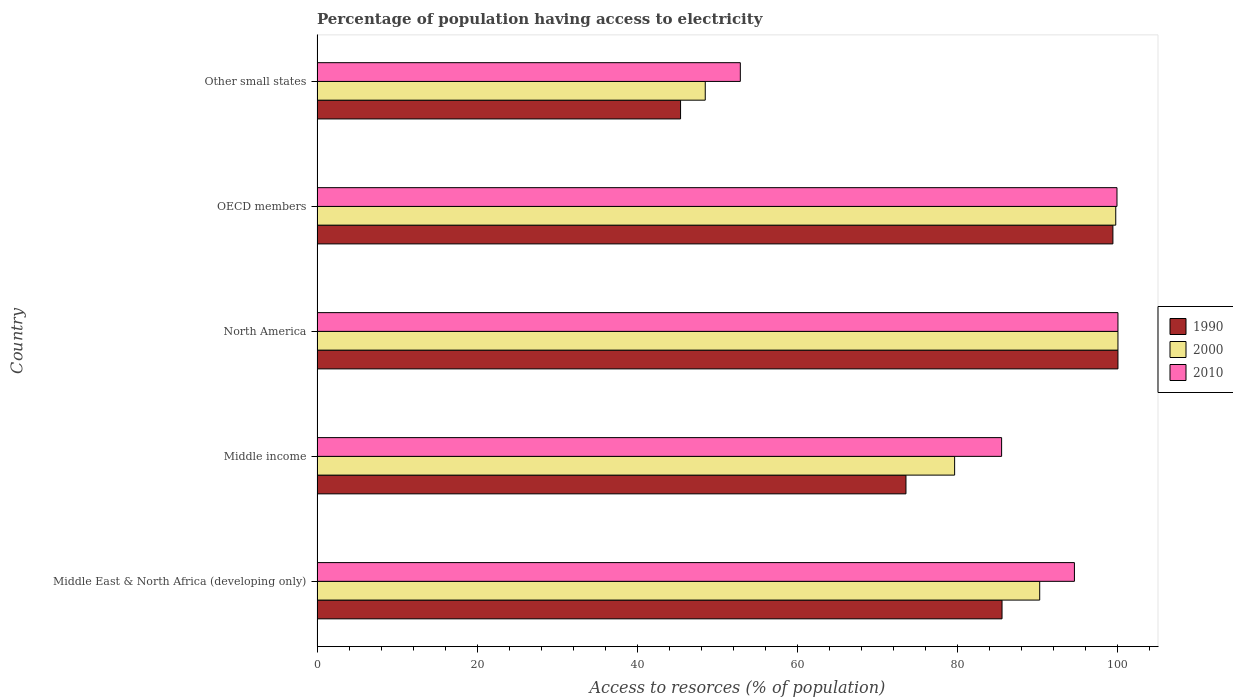How many different coloured bars are there?
Give a very brief answer. 3. What is the label of the 4th group of bars from the top?
Your response must be concise. Middle income. In how many cases, is the number of bars for a given country not equal to the number of legend labels?
Keep it short and to the point. 0. What is the percentage of population having access to electricity in 2000 in OECD members?
Your answer should be compact. 99.72. Across all countries, what is the maximum percentage of population having access to electricity in 2000?
Offer a terse response. 100. Across all countries, what is the minimum percentage of population having access to electricity in 2010?
Your answer should be compact. 52.85. In which country was the percentage of population having access to electricity in 2010 minimum?
Make the answer very short. Other small states. What is the total percentage of population having access to electricity in 1990 in the graph?
Ensure brevity in your answer.  403.82. What is the difference between the percentage of population having access to electricity in 2000 in OECD members and that in Other small states?
Provide a succinct answer. 51.25. What is the difference between the percentage of population having access to electricity in 2000 in Middle income and the percentage of population having access to electricity in 2010 in Middle East & North Africa (developing only)?
Make the answer very short. -14.96. What is the average percentage of population having access to electricity in 2000 per country?
Offer a very short reply. 83.61. What is the difference between the percentage of population having access to electricity in 1990 and percentage of population having access to electricity in 2000 in North America?
Offer a terse response. 0. What is the ratio of the percentage of population having access to electricity in 1990 in North America to that in OECD members?
Provide a succinct answer. 1.01. Is the percentage of population having access to electricity in 2010 in OECD members less than that in Other small states?
Provide a succinct answer. No. What is the difference between the highest and the second highest percentage of population having access to electricity in 1990?
Provide a short and direct response. 0.63. What is the difference between the highest and the lowest percentage of population having access to electricity in 1990?
Make the answer very short. 54.61. In how many countries, is the percentage of population having access to electricity in 1990 greater than the average percentage of population having access to electricity in 1990 taken over all countries?
Make the answer very short. 3. What does the 3rd bar from the bottom in Middle income represents?
Offer a very short reply. 2010. How many countries are there in the graph?
Your answer should be compact. 5. Does the graph contain grids?
Your answer should be compact. No. Where does the legend appear in the graph?
Your answer should be compact. Center right. How are the legend labels stacked?
Offer a very short reply. Vertical. What is the title of the graph?
Provide a short and direct response. Percentage of population having access to electricity. Does "2007" appear as one of the legend labels in the graph?
Your answer should be very brief. No. What is the label or title of the X-axis?
Offer a very short reply. Access to resorces (% of population). What is the label or title of the Y-axis?
Offer a very short reply. Country. What is the Access to resorces (% of population) of 1990 in Middle East & North Africa (developing only)?
Keep it short and to the point. 85.53. What is the Access to resorces (% of population) in 2000 in Middle East & North Africa (developing only)?
Your response must be concise. 90.23. What is the Access to resorces (% of population) of 2010 in Middle East & North Africa (developing only)?
Offer a very short reply. 94.57. What is the Access to resorces (% of population) in 1990 in Middle income?
Provide a short and direct response. 73.53. What is the Access to resorces (% of population) of 2000 in Middle income?
Offer a very short reply. 79.61. What is the Access to resorces (% of population) in 2010 in Middle income?
Your answer should be very brief. 85.47. What is the Access to resorces (% of population) of 1990 in North America?
Offer a terse response. 100. What is the Access to resorces (% of population) in 2000 in North America?
Provide a short and direct response. 100. What is the Access to resorces (% of population) of 2010 in North America?
Offer a very short reply. 100. What is the Access to resorces (% of population) of 1990 in OECD members?
Provide a short and direct response. 99.37. What is the Access to resorces (% of population) in 2000 in OECD members?
Give a very brief answer. 99.72. What is the Access to resorces (% of population) in 2010 in OECD members?
Your answer should be very brief. 99.88. What is the Access to resorces (% of population) of 1990 in Other small states?
Your answer should be very brief. 45.39. What is the Access to resorces (% of population) in 2000 in Other small states?
Your answer should be very brief. 48.47. What is the Access to resorces (% of population) of 2010 in Other small states?
Provide a succinct answer. 52.85. Across all countries, what is the maximum Access to resorces (% of population) of 2000?
Ensure brevity in your answer.  100. Across all countries, what is the minimum Access to resorces (% of population) of 1990?
Your answer should be compact. 45.39. Across all countries, what is the minimum Access to resorces (% of population) of 2000?
Keep it short and to the point. 48.47. Across all countries, what is the minimum Access to resorces (% of population) in 2010?
Ensure brevity in your answer.  52.85. What is the total Access to resorces (% of population) of 1990 in the graph?
Your answer should be very brief. 403.82. What is the total Access to resorces (% of population) in 2000 in the graph?
Offer a terse response. 418.03. What is the total Access to resorces (% of population) of 2010 in the graph?
Provide a short and direct response. 432.77. What is the difference between the Access to resorces (% of population) of 1990 in Middle East & North Africa (developing only) and that in Middle income?
Offer a very short reply. 12. What is the difference between the Access to resorces (% of population) of 2000 in Middle East & North Africa (developing only) and that in Middle income?
Offer a terse response. 10.62. What is the difference between the Access to resorces (% of population) in 2010 in Middle East & North Africa (developing only) and that in Middle income?
Provide a short and direct response. 9.09. What is the difference between the Access to resorces (% of population) in 1990 in Middle East & North Africa (developing only) and that in North America?
Make the answer very short. -14.47. What is the difference between the Access to resorces (% of population) of 2000 in Middle East & North Africa (developing only) and that in North America?
Offer a terse response. -9.77. What is the difference between the Access to resorces (% of population) of 2010 in Middle East & North Africa (developing only) and that in North America?
Offer a very short reply. -5.43. What is the difference between the Access to resorces (% of population) of 1990 in Middle East & North Africa (developing only) and that in OECD members?
Provide a succinct answer. -13.84. What is the difference between the Access to resorces (% of population) in 2000 in Middle East & North Africa (developing only) and that in OECD members?
Make the answer very short. -9.49. What is the difference between the Access to resorces (% of population) of 2010 in Middle East & North Africa (developing only) and that in OECD members?
Offer a terse response. -5.31. What is the difference between the Access to resorces (% of population) of 1990 in Middle East & North Africa (developing only) and that in Other small states?
Keep it short and to the point. 40.14. What is the difference between the Access to resorces (% of population) of 2000 in Middle East & North Africa (developing only) and that in Other small states?
Make the answer very short. 41.76. What is the difference between the Access to resorces (% of population) of 2010 in Middle East & North Africa (developing only) and that in Other small states?
Give a very brief answer. 41.72. What is the difference between the Access to resorces (% of population) of 1990 in Middle income and that in North America?
Provide a short and direct response. -26.47. What is the difference between the Access to resorces (% of population) of 2000 in Middle income and that in North America?
Make the answer very short. -20.39. What is the difference between the Access to resorces (% of population) in 2010 in Middle income and that in North America?
Make the answer very short. -14.53. What is the difference between the Access to resorces (% of population) of 1990 in Middle income and that in OECD members?
Your response must be concise. -25.84. What is the difference between the Access to resorces (% of population) of 2000 in Middle income and that in OECD members?
Your answer should be very brief. -20.12. What is the difference between the Access to resorces (% of population) of 2010 in Middle income and that in OECD members?
Make the answer very short. -14.41. What is the difference between the Access to resorces (% of population) in 1990 in Middle income and that in Other small states?
Provide a succinct answer. 28.14. What is the difference between the Access to resorces (% of population) in 2000 in Middle income and that in Other small states?
Your response must be concise. 31.14. What is the difference between the Access to resorces (% of population) in 2010 in Middle income and that in Other small states?
Give a very brief answer. 32.62. What is the difference between the Access to resorces (% of population) of 1990 in North America and that in OECD members?
Your response must be concise. 0.63. What is the difference between the Access to resorces (% of population) of 2000 in North America and that in OECD members?
Offer a very short reply. 0.28. What is the difference between the Access to resorces (% of population) of 2010 in North America and that in OECD members?
Your answer should be compact. 0.12. What is the difference between the Access to resorces (% of population) in 1990 in North America and that in Other small states?
Your answer should be very brief. 54.61. What is the difference between the Access to resorces (% of population) of 2000 in North America and that in Other small states?
Your response must be concise. 51.53. What is the difference between the Access to resorces (% of population) in 2010 in North America and that in Other small states?
Provide a short and direct response. 47.15. What is the difference between the Access to resorces (% of population) of 1990 in OECD members and that in Other small states?
Ensure brevity in your answer.  53.98. What is the difference between the Access to resorces (% of population) in 2000 in OECD members and that in Other small states?
Offer a very short reply. 51.25. What is the difference between the Access to resorces (% of population) of 2010 in OECD members and that in Other small states?
Provide a succinct answer. 47.03. What is the difference between the Access to resorces (% of population) of 1990 in Middle East & North Africa (developing only) and the Access to resorces (% of population) of 2000 in Middle income?
Your response must be concise. 5.92. What is the difference between the Access to resorces (% of population) in 1990 in Middle East & North Africa (developing only) and the Access to resorces (% of population) in 2010 in Middle income?
Your answer should be very brief. 0.05. What is the difference between the Access to resorces (% of population) in 2000 in Middle East & North Africa (developing only) and the Access to resorces (% of population) in 2010 in Middle income?
Make the answer very short. 4.76. What is the difference between the Access to resorces (% of population) of 1990 in Middle East & North Africa (developing only) and the Access to resorces (% of population) of 2000 in North America?
Offer a terse response. -14.47. What is the difference between the Access to resorces (% of population) of 1990 in Middle East & North Africa (developing only) and the Access to resorces (% of population) of 2010 in North America?
Your answer should be very brief. -14.47. What is the difference between the Access to resorces (% of population) of 2000 in Middle East & North Africa (developing only) and the Access to resorces (% of population) of 2010 in North America?
Your response must be concise. -9.77. What is the difference between the Access to resorces (% of population) in 1990 in Middle East & North Africa (developing only) and the Access to resorces (% of population) in 2000 in OECD members?
Your response must be concise. -14.2. What is the difference between the Access to resorces (% of population) in 1990 in Middle East & North Africa (developing only) and the Access to resorces (% of population) in 2010 in OECD members?
Your answer should be very brief. -14.35. What is the difference between the Access to resorces (% of population) of 2000 in Middle East & North Africa (developing only) and the Access to resorces (% of population) of 2010 in OECD members?
Provide a succinct answer. -9.65. What is the difference between the Access to resorces (% of population) of 1990 in Middle East & North Africa (developing only) and the Access to resorces (% of population) of 2000 in Other small states?
Provide a short and direct response. 37.06. What is the difference between the Access to resorces (% of population) of 1990 in Middle East & North Africa (developing only) and the Access to resorces (% of population) of 2010 in Other small states?
Your answer should be compact. 32.68. What is the difference between the Access to resorces (% of population) of 2000 in Middle East & North Africa (developing only) and the Access to resorces (% of population) of 2010 in Other small states?
Make the answer very short. 37.38. What is the difference between the Access to resorces (% of population) in 1990 in Middle income and the Access to resorces (% of population) in 2000 in North America?
Your answer should be very brief. -26.47. What is the difference between the Access to resorces (% of population) in 1990 in Middle income and the Access to resorces (% of population) in 2010 in North America?
Keep it short and to the point. -26.47. What is the difference between the Access to resorces (% of population) of 2000 in Middle income and the Access to resorces (% of population) of 2010 in North America?
Offer a very short reply. -20.39. What is the difference between the Access to resorces (% of population) in 1990 in Middle income and the Access to resorces (% of population) in 2000 in OECD members?
Keep it short and to the point. -26.19. What is the difference between the Access to resorces (% of population) in 1990 in Middle income and the Access to resorces (% of population) in 2010 in OECD members?
Make the answer very short. -26.35. What is the difference between the Access to resorces (% of population) in 2000 in Middle income and the Access to resorces (% of population) in 2010 in OECD members?
Provide a succinct answer. -20.27. What is the difference between the Access to resorces (% of population) of 1990 in Middle income and the Access to resorces (% of population) of 2000 in Other small states?
Provide a succinct answer. 25.06. What is the difference between the Access to resorces (% of population) of 1990 in Middle income and the Access to resorces (% of population) of 2010 in Other small states?
Your answer should be very brief. 20.68. What is the difference between the Access to resorces (% of population) of 2000 in Middle income and the Access to resorces (% of population) of 2010 in Other small states?
Your answer should be compact. 26.76. What is the difference between the Access to resorces (% of population) of 1990 in North America and the Access to resorces (% of population) of 2000 in OECD members?
Make the answer very short. 0.28. What is the difference between the Access to resorces (% of population) of 1990 in North America and the Access to resorces (% of population) of 2010 in OECD members?
Your response must be concise. 0.12. What is the difference between the Access to resorces (% of population) of 2000 in North America and the Access to resorces (% of population) of 2010 in OECD members?
Make the answer very short. 0.12. What is the difference between the Access to resorces (% of population) in 1990 in North America and the Access to resorces (% of population) in 2000 in Other small states?
Offer a very short reply. 51.53. What is the difference between the Access to resorces (% of population) of 1990 in North America and the Access to resorces (% of population) of 2010 in Other small states?
Your answer should be compact. 47.15. What is the difference between the Access to resorces (% of population) in 2000 in North America and the Access to resorces (% of population) in 2010 in Other small states?
Keep it short and to the point. 47.15. What is the difference between the Access to resorces (% of population) in 1990 in OECD members and the Access to resorces (% of population) in 2000 in Other small states?
Provide a succinct answer. 50.9. What is the difference between the Access to resorces (% of population) of 1990 in OECD members and the Access to resorces (% of population) of 2010 in Other small states?
Your answer should be very brief. 46.52. What is the difference between the Access to resorces (% of population) in 2000 in OECD members and the Access to resorces (% of population) in 2010 in Other small states?
Provide a succinct answer. 46.88. What is the average Access to resorces (% of population) of 1990 per country?
Provide a succinct answer. 80.76. What is the average Access to resorces (% of population) in 2000 per country?
Make the answer very short. 83.61. What is the average Access to resorces (% of population) in 2010 per country?
Offer a terse response. 86.55. What is the difference between the Access to resorces (% of population) in 1990 and Access to resorces (% of population) in 2000 in Middle East & North Africa (developing only)?
Provide a short and direct response. -4.7. What is the difference between the Access to resorces (% of population) in 1990 and Access to resorces (% of population) in 2010 in Middle East & North Africa (developing only)?
Offer a terse response. -9.04. What is the difference between the Access to resorces (% of population) of 2000 and Access to resorces (% of population) of 2010 in Middle East & North Africa (developing only)?
Your answer should be compact. -4.34. What is the difference between the Access to resorces (% of population) in 1990 and Access to resorces (% of population) in 2000 in Middle income?
Provide a short and direct response. -6.08. What is the difference between the Access to resorces (% of population) in 1990 and Access to resorces (% of population) in 2010 in Middle income?
Offer a very short reply. -11.94. What is the difference between the Access to resorces (% of population) in 2000 and Access to resorces (% of population) in 2010 in Middle income?
Make the answer very short. -5.87. What is the difference between the Access to resorces (% of population) in 1990 and Access to resorces (% of population) in 2000 in North America?
Make the answer very short. 0. What is the difference between the Access to resorces (% of population) of 1990 and Access to resorces (% of population) of 2010 in North America?
Offer a terse response. 0. What is the difference between the Access to resorces (% of population) of 1990 and Access to resorces (% of population) of 2000 in OECD members?
Your answer should be compact. -0.35. What is the difference between the Access to resorces (% of population) in 1990 and Access to resorces (% of population) in 2010 in OECD members?
Provide a succinct answer. -0.51. What is the difference between the Access to resorces (% of population) in 2000 and Access to resorces (% of population) in 2010 in OECD members?
Ensure brevity in your answer.  -0.15. What is the difference between the Access to resorces (% of population) of 1990 and Access to resorces (% of population) of 2000 in Other small states?
Offer a terse response. -3.08. What is the difference between the Access to resorces (% of population) of 1990 and Access to resorces (% of population) of 2010 in Other small states?
Give a very brief answer. -7.46. What is the difference between the Access to resorces (% of population) in 2000 and Access to resorces (% of population) in 2010 in Other small states?
Provide a succinct answer. -4.38. What is the ratio of the Access to resorces (% of population) of 1990 in Middle East & North Africa (developing only) to that in Middle income?
Your answer should be compact. 1.16. What is the ratio of the Access to resorces (% of population) in 2000 in Middle East & North Africa (developing only) to that in Middle income?
Provide a short and direct response. 1.13. What is the ratio of the Access to resorces (% of population) of 2010 in Middle East & North Africa (developing only) to that in Middle income?
Your answer should be compact. 1.11. What is the ratio of the Access to resorces (% of population) in 1990 in Middle East & North Africa (developing only) to that in North America?
Give a very brief answer. 0.86. What is the ratio of the Access to resorces (% of population) of 2000 in Middle East & North Africa (developing only) to that in North America?
Your answer should be very brief. 0.9. What is the ratio of the Access to resorces (% of population) in 2010 in Middle East & North Africa (developing only) to that in North America?
Provide a succinct answer. 0.95. What is the ratio of the Access to resorces (% of population) of 1990 in Middle East & North Africa (developing only) to that in OECD members?
Provide a short and direct response. 0.86. What is the ratio of the Access to resorces (% of population) of 2000 in Middle East & North Africa (developing only) to that in OECD members?
Offer a terse response. 0.9. What is the ratio of the Access to resorces (% of population) of 2010 in Middle East & North Africa (developing only) to that in OECD members?
Offer a very short reply. 0.95. What is the ratio of the Access to resorces (% of population) in 1990 in Middle East & North Africa (developing only) to that in Other small states?
Your response must be concise. 1.88. What is the ratio of the Access to resorces (% of population) of 2000 in Middle East & North Africa (developing only) to that in Other small states?
Give a very brief answer. 1.86. What is the ratio of the Access to resorces (% of population) in 2010 in Middle East & North Africa (developing only) to that in Other small states?
Your response must be concise. 1.79. What is the ratio of the Access to resorces (% of population) of 1990 in Middle income to that in North America?
Keep it short and to the point. 0.74. What is the ratio of the Access to resorces (% of population) in 2000 in Middle income to that in North America?
Keep it short and to the point. 0.8. What is the ratio of the Access to resorces (% of population) of 2010 in Middle income to that in North America?
Give a very brief answer. 0.85. What is the ratio of the Access to resorces (% of population) in 1990 in Middle income to that in OECD members?
Offer a terse response. 0.74. What is the ratio of the Access to resorces (% of population) of 2000 in Middle income to that in OECD members?
Give a very brief answer. 0.8. What is the ratio of the Access to resorces (% of population) of 2010 in Middle income to that in OECD members?
Your response must be concise. 0.86. What is the ratio of the Access to resorces (% of population) in 1990 in Middle income to that in Other small states?
Provide a short and direct response. 1.62. What is the ratio of the Access to resorces (% of population) in 2000 in Middle income to that in Other small states?
Your answer should be compact. 1.64. What is the ratio of the Access to resorces (% of population) of 2010 in Middle income to that in Other small states?
Ensure brevity in your answer.  1.62. What is the ratio of the Access to resorces (% of population) of 1990 in North America to that in Other small states?
Offer a terse response. 2.2. What is the ratio of the Access to resorces (% of population) of 2000 in North America to that in Other small states?
Keep it short and to the point. 2.06. What is the ratio of the Access to resorces (% of population) in 2010 in North America to that in Other small states?
Provide a succinct answer. 1.89. What is the ratio of the Access to resorces (% of population) of 1990 in OECD members to that in Other small states?
Provide a short and direct response. 2.19. What is the ratio of the Access to resorces (% of population) of 2000 in OECD members to that in Other small states?
Offer a very short reply. 2.06. What is the ratio of the Access to resorces (% of population) of 2010 in OECD members to that in Other small states?
Your answer should be compact. 1.89. What is the difference between the highest and the second highest Access to resorces (% of population) of 1990?
Make the answer very short. 0.63. What is the difference between the highest and the second highest Access to resorces (% of population) in 2000?
Provide a short and direct response. 0.28. What is the difference between the highest and the second highest Access to resorces (% of population) of 2010?
Offer a terse response. 0.12. What is the difference between the highest and the lowest Access to resorces (% of population) of 1990?
Your answer should be compact. 54.61. What is the difference between the highest and the lowest Access to resorces (% of population) of 2000?
Provide a succinct answer. 51.53. What is the difference between the highest and the lowest Access to resorces (% of population) of 2010?
Keep it short and to the point. 47.15. 